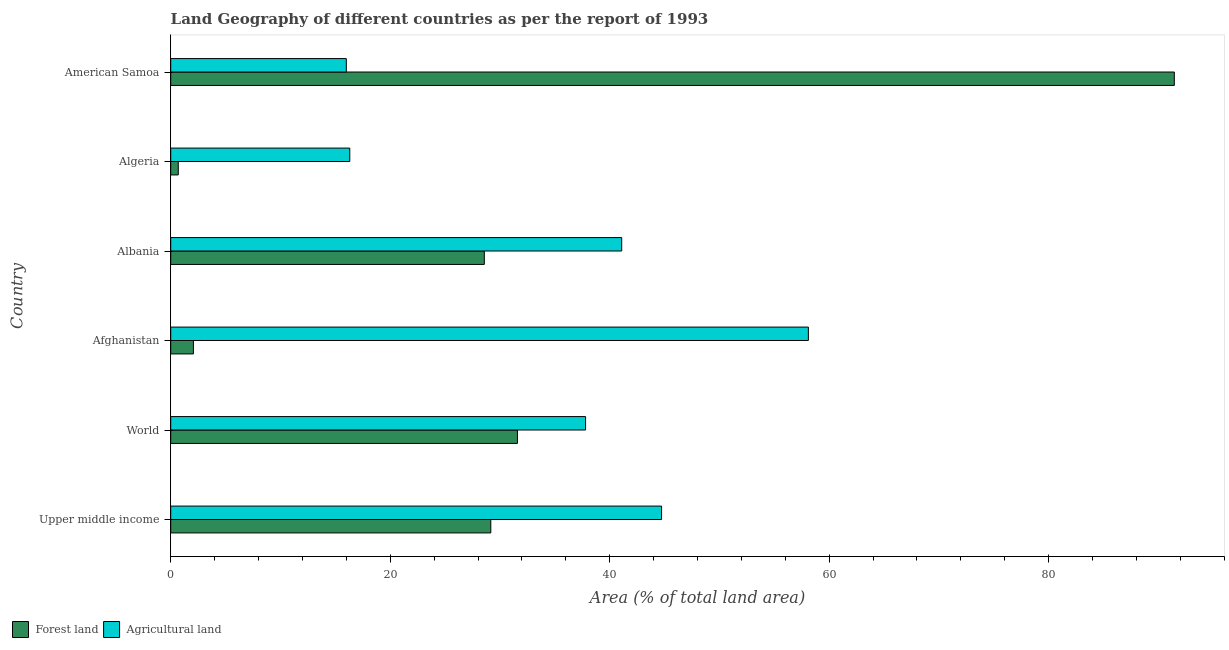Are the number of bars on each tick of the Y-axis equal?
Your response must be concise. Yes. In how many cases, is the number of bars for a given country not equal to the number of legend labels?
Keep it short and to the point. 0. What is the percentage of land area under forests in Afghanistan?
Make the answer very short. 2.07. Across all countries, what is the maximum percentage of land area under forests?
Provide a succinct answer. 91.45. In which country was the percentage of land area under forests maximum?
Provide a short and direct response. American Samoa. In which country was the percentage of land area under forests minimum?
Provide a succinct answer. Algeria. What is the total percentage of land area under forests in the graph?
Your answer should be very brief. 183.54. What is the difference between the percentage of land area under agriculture in Afghanistan and that in Albania?
Your answer should be compact. 17.01. What is the difference between the percentage of land area under agriculture in World and the percentage of land area under forests in Upper middle income?
Your answer should be very brief. 8.64. What is the average percentage of land area under forests per country?
Keep it short and to the point. 30.59. What is the difference between the percentage of land area under agriculture and percentage of land area under forests in American Samoa?
Provide a short and direct response. -75.45. Is the percentage of land area under forests in Afghanistan less than that in Albania?
Offer a very short reply. Yes. What is the difference between the highest and the second highest percentage of land area under agriculture?
Offer a very short reply. 13.38. What is the difference between the highest and the lowest percentage of land area under forests?
Offer a terse response. 90.76. Is the sum of the percentage of land area under agriculture in American Samoa and Upper middle income greater than the maximum percentage of land area under forests across all countries?
Your response must be concise. No. What does the 1st bar from the top in Albania represents?
Offer a very short reply. Agricultural land. What does the 1st bar from the bottom in World represents?
Provide a succinct answer. Forest land. How many bars are there?
Make the answer very short. 12. What is the difference between two consecutive major ticks on the X-axis?
Offer a very short reply. 20. Are the values on the major ticks of X-axis written in scientific E-notation?
Give a very brief answer. No. Does the graph contain any zero values?
Offer a terse response. No. Does the graph contain grids?
Provide a short and direct response. No. How many legend labels are there?
Offer a very short reply. 2. How are the legend labels stacked?
Provide a short and direct response. Horizontal. What is the title of the graph?
Make the answer very short. Land Geography of different countries as per the report of 1993. What is the label or title of the X-axis?
Provide a short and direct response. Area (% of total land area). What is the Area (% of total land area) of Forest land in Upper middle income?
Make the answer very short. 29.17. What is the Area (% of total land area) of Agricultural land in Upper middle income?
Ensure brevity in your answer.  44.73. What is the Area (% of total land area) of Forest land in World?
Ensure brevity in your answer.  31.59. What is the Area (% of total land area) in Agricultural land in World?
Your response must be concise. 37.8. What is the Area (% of total land area) of Forest land in Afghanistan?
Make the answer very short. 2.07. What is the Area (% of total land area) of Agricultural land in Afghanistan?
Provide a succinct answer. 58.1. What is the Area (% of total land area) of Forest land in Albania?
Provide a succinct answer. 28.57. What is the Area (% of total land area) in Agricultural land in Albania?
Make the answer very short. 41.09. What is the Area (% of total land area) of Forest land in Algeria?
Offer a very short reply. 0.69. What is the Area (% of total land area) in Agricultural land in Algeria?
Your answer should be very brief. 16.32. What is the Area (% of total land area) in Forest land in American Samoa?
Keep it short and to the point. 91.45. Across all countries, what is the maximum Area (% of total land area) of Forest land?
Offer a terse response. 91.45. Across all countries, what is the maximum Area (% of total land area) in Agricultural land?
Make the answer very short. 58.1. Across all countries, what is the minimum Area (% of total land area) of Forest land?
Offer a very short reply. 0.69. Across all countries, what is the minimum Area (% of total land area) of Agricultural land?
Your answer should be compact. 16. What is the total Area (% of total land area) of Forest land in the graph?
Provide a short and direct response. 183.54. What is the total Area (% of total land area) in Agricultural land in the graph?
Your answer should be compact. 214.05. What is the difference between the Area (% of total land area) of Forest land in Upper middle income and that in World?
Your response must be concise. -2.43. What is the difference between the Area (% of total land area) of Agricultural land in Upper middle income and that in World?
Offer a terse response. 6.93. What is the difference between the Area (% of total land area) in Forest land in Upper middle income and that in Afghanistan?
Give a very brief answer. 27.1. What is the difference between the Area (% of total land area) in Agricultural land in Upper middle income and that in Afghanistan?
Your answer should be compact. -13.38. What is the difference between the Area (% of total land area) in Forest land in Upper middle income and that in Albania?
Give a very brief answer. 0.59. What is the difference between the Area (% of total land area) of Agricultural land in Upper middle income and that in Albania?
Your answer should be very brief. 3.63. What is the difference between the Area (% of total land area) in Forest land in Upper middle income and that in Algeria?
Provide a short and direct response. 28.48. What is the difference between the Area (% of total land area) in Agricultural land in Upper middle income and that in Algeria?
Your answer should be compact. 28.41. What is the difference between the Area (% of total land area) of Forest land in Upper middle income and that in American Samoa?
Your response must be concise. -62.28. What is the difference between the Area (% of total land area) of Agricultural land in Upper middle income and that in American Samoa?
Ensure brevity in your answer.  28.73. What is the difference between the Area (% of total land area) of Forest land in World and that in Afghanistan?
Your response must be concise. 29.53. What is the difference between the Area (% of total land area) of Agricultural land in World and that in Afghanistan?
Your response must be concise. -20.3. What is the difference between the Area (% of total land area) in Forest land in World and that in Albania?
Give a very brief answer. 3.02. What is the difference between the Area (% of total land area) in Agricultural land in World and that in Albania?
Ensure brevity in your answer.  -3.29. What is the difference between the Area (% of total land area) in Forest land in World and that in Algeria?
Your answer should be compact. 30.91. What is the difference between the Area (% of total land area) of Agricultural land in World and that in Algeria?
Provide a succinct answer. 21.49. What is the difference between the Area (% of total land area) in Forest land in World and that in American Samoa?
Ensure brevity in your answer.  -59.86. What is the difference between the Area (% of total land area) in Agricultural land in World and that in American Samoa?
Your answer should be very brief. 21.8. What is the difference between the Area (% of total land area) of Forest land in Afghanistan and that in Albania?
Keep it short and to the point. -26.51. What is the difference between the Area (% of total land area) of Agricultural land in Afghanistan and that in Albania?
Your response must be concise. 17.01. What is the difference between the Area (% of total land area) of Forest land in Afghanistan and that in Algeria?
Ensure brevity in your answer.  1.38. What is the difference between the Area (% of total land area) of Agricultural land in Afghanistan and that in Algeria?
Offer a terse response. 41.79. What is the difference between the Area (% of total land area) of Forest land in Afghanistan and that in American Samoa?
Your response must be concise. -89.38. What is the difference between the Area (% of total land area) of Agricultural land in Afghanistan and that in American Samoa?
Keep it short and to the point. 42.1. What is the difference between the Area (% of total land area) of Forest land in Albania and that in Algeria?
Offer a terse response. 27.89. What is the difference between the Area (% of total land area) of Agricultural land in Albania and that in Algeria?
Make the answer very short. 24.78. What is the difference between the Area (% of total land area) in Forest land in Albania and that in American Samoa?
Your answer should be very brief. -62.88. What is the difference between the Area (% of total land area) of Agricultural land in Albania and that in American Samoa?
Offer a terse response. 25.09. What is the difference between the Area (% of total land area) in Forest land in Algeria and that in American Samoa?
Make the answer very short. -90.76. What is the difference between the Area (% of total land area) in Agricultural land in Algeria and that in American Samoa?
Provide a succinct answer. 0.32. What is the difference between the Area (% of total land area) in Forest land in Upper middle income and the Area (% of total land area) in Agricultural land in World?
Offer a very short reply. -8.64. What is the difference between the Area (% of total land area) in Forest land in Upper middle income and the Area (% of total land area) in Agricultural land in Afghanistan?
Your answer should be very brief. -28.94. What is the difference between the Area (% of total land area) in Forest land in Upper middle income and the Area (% of total land area) in Agricultural land in Albania?
Keep it short and to the point. -11.93. What is the difference between the Area (% of total land area) in Forest land in Upper middle income and the Area (% of total land area) in Agricultural land in Algeria?
Keep it short and to the point. 12.85. What is the difference between the Area (% of total land area) in Forest land in Upper middle income and the Area (% of total land area) in Agricultural land in American Samoa?
Your response must be concise. 13.17. What is the difference between the Area (% of total land area) in Forest land in World and the Area (% of total land area) in Agricultural land in Afghanistan?
Offer a very short reply. -26.51. What is the difference between the Area (% of total land area) of Forest land in World and the Area (% of total land area) of Agricultural land in Albania?
Make the answer very short. -9.5. What is the difference between the Area (% of total land area) in Forest land in World and the Area (% of total land area) in Agricultural land in Algeria?
Your response must be concise. 15.28. What is the difference between the Area (% of total land area) in Forest land in World and the Area (% of total land area) in Agricultural land in American Samoa?
Keep it short and to the point. 15.59. What is the difference between the Area (% of total land area) in Forest land in Afghanistan and the Area (% of total land area) in Agricultural land in Albania?
Ensure brevity in your answer.  -39.03. What is the difference between the Area (% of total land area) in Forest land in Afghanistan and the Area (% of total land area) in Agricultural land in Algeria?
Give a very brief answer. -14.25. What is the difference between the Area (% of total land area) of Forest land in Afghanistan and the Area (% of total land area) of Agricultural land in American Samoa?
Ensure brevity in your answer.  -13.93. What is the difference between the Area (% of total land area) of Forest land in Albania and the Area (% of total land area) of Agricultural land in Algeria?
Offer a terse response. 12.26. What is the difference between the Area (% of total land area) in Forest land in Albania and the Area (% of total land area) in Agricultural land in American Samoa?
Offer a terse response. 12.57. What is the difference between the Area (% of total land area) in Forest land in Algeria and the Area (% of total land area) in Agricultural land in American Samoa?
Your response must be concise. -15.31. What is the average Area (% of total land area) of Forest land per country?
Ensure brevity in your answer.  30.59. What is the average Area (% of total land area) of Agricultural land per country?
Make the answer very short. 35.67. What is the difference between the Area (% of total land area) of Forest land and Area (% of total land area) of Agricultural land in Upper middle income?
Your response must be concise. -15.56. What is the difference between the Area (% of total land area) in Forest land and Area (% of total land area) in Agricultural land in World?
Provide a succinct answer. -6.21. What is the difference between the Area (% of total land area) of Forest land and Area (% of total land area) of Agricultural land in Afghanistan?
Provide a succinct answer. -56.04. What is the difference between the Area (% of total land area) in Forest land and Area (% of total land area) in Agricultural land in Albania?
Give a very brief answer. -12.52. What is the difference between the Area (% of total land area) in Forest land and Area (% of total land area) in Agricultural land in Algeria?
Ensure brevity in your answer.  -15.63. What is the difference between the Area (% of total land area) in Forest land and Area (% of total land area) in Agricultural land in American Samoa?
Ensure brevity in your answer.  75.45. What is the ratio of the Area (% of total land area) of Forest land in Upper middle income to that in World?
Your answer should be compact. 0.92. What is the ratio of the Area (% of total land area) in Agricultural land in Upper middle income to that in World?
Offer a very short reply. 1.18. What is the ratio of the Area (% of total land area) of Forest land in Upper middle income to that in Afghanistan?
Make the answer very short. 14.11. What is the ratio of the Area (% of total land area) of Agricultural land in Upper middle income to that in Afghanistan?
Keep it short and to the point. 0.77. What is the ratio of the Area (% of total land area) in Forest land in Upper middle income to that in Albania?
Provide a succinct answer. 1.02. What is the ratio of the Area (% of total land area) of Agricultural land in Upper middle income to that in Albania?
Provide a short and direct response. 1.09. What is the ratio of the Area (% of total land area) of Forest land in Upper middle income to that in Algeria?
Keep it short and to the point. 42.34. What is the ratio of the Area (% of total land area) in Agricultural land in Upper middle income to that in Algeria?
Your answer should be very brief. 2.74. What is the ratio of the Area (% of total land area) in Forest land in Upper middle income to that in American Samoa?
Make the answer very short. 0.32. What is the ratio of the Area (% of total land area) of Agricultural land in Upper middle income to that in American Samoa?
Your answer should be compact. 2.8. What is the ratio of the Area (% of total land area) in Forest land in World to that in Afghanistan?
Make the answer very short. 15.28. What is the ratio of the Area (% of total land area) of Agricultural land in World to that in Afghanistan?
Your answer should be very brief. 0.65. What is the ratio of the Area (% of total land area) of Forest land in World to that in Albania?
Your response must be concise. 1.11. What is the ratio of the Area (% of total land area) of Agricultural land in World to that in Albania?
Offer a terse response. 0.92. What is the ratio of the Area (% of total land area) of Forest land in World to that in Algeria?
Your answer should be very brief. 45.87. What is the ratio of the Area (% of total land area) in Agricultural land in World to that in Algeria?
Provide a succinct answer. 2.32. What is the ratio of the Area (% of total land area) in Forest land in World to that in American Samoa?
Ensure brevity in your answer.  0.35. What is the ratio of the Area (% of total land area) in Agricultural land in World to that in American Samoa?
Keep it short and to the point. 2.36. What is the ratio of the Area (% of total land area) in Forest land in Afghanistan to that in Albania?
Your response must be concise. 0.07. What is the ratio of the Area (% of total land area) in Agricultural land in Afghanistan to that in Albania?
Provide a succinct answer. 1.41. What is the ratio of the Area (% of total land area) of Forest land in Afghanistan to that in Algeria?
Ensure brevity in your answer.  3. What is the ratio of the Area (% of total land area) in Agricultural land in Afghanistan to that in Algeria?
Offer a terse response. 3.56. What is the ratio of the Area (% of total land area) in Forest land in Afghanistan to that in American Samoa?
Make the answer very short. 0.02. What is the ratio of the Area (% of total land area) of Agricultural land in Afghanistan to that in American Samoa?
Give a very brief answer. 3.63. What is the ratio of the Area (% of total land area) in Forest land in Albania to that in Algeria?
Provide a succinct answer. 41.48. What is the ratio of the Area (% of total land area) of Agricultural land in Albania to that in Algeria?
Your answer should be very brief. 2.52. What is the ratio of the Area (% of total land area) in Forest land in Albania to that in American Samoa?
Provide a succinct answer. 0.31. What is the ratio of the Area (% of total land area) in Agricultural land in Albania to that in American Samoa?
Give a very brief answer. 2.57. What is the ratio of the Area (% of total land area) in Forest land in Algeria to that in American Samoa?
Provide a succinct answer. 0.01. What is the ratio of the Area (% of total land area) of Agricultural land in Algeria to that in American Samoa?
Ensure brevity in your answer.  1.02. What is the difference between the highest and the second highest Area (% of total land area) in Forest land?
Your response must be concise. 59.86. What is the difference between the highest and the second highest Area (% of total land area) of Agricultural land?
Keep it short and to the point. 13.38. What is the difference between the highest and the lowest Area (% of total land area) in Forest land?
Offer a very short reply. 90.76. What is the difference between the highest and the lowest Area (% of total land area) of Agricultural land?
Provide a short and direct response. 42.1. 